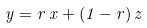Convert formula to latex. <formula><loc_0><loc_0><loc_500><loc_500>y = r \, x + ( 1 - r ) \, z</formula> 